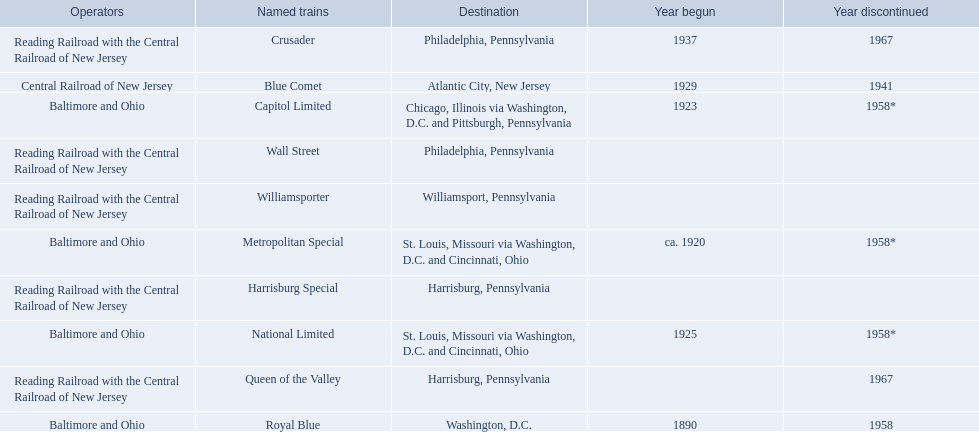Which operators are the reading railroad with the central railroad of new jersey? Reading Railroad with the Central Railroad of New Jersey, Reading Railroad with the Central Railroad of New Jersey, Reading Railroad with the Central Railroad of New Jersey, Reading Railroad with the Central Railroad of New Jersey, Reading Railroad with the Central Railroad of New Jersey. Which destinations are philadelphia, pennsylvania? Philadelphia, Pennsylvania, Philadelphia, Pennsylvania. What on began in 1937? 1937. What is the named train? Crusader. 